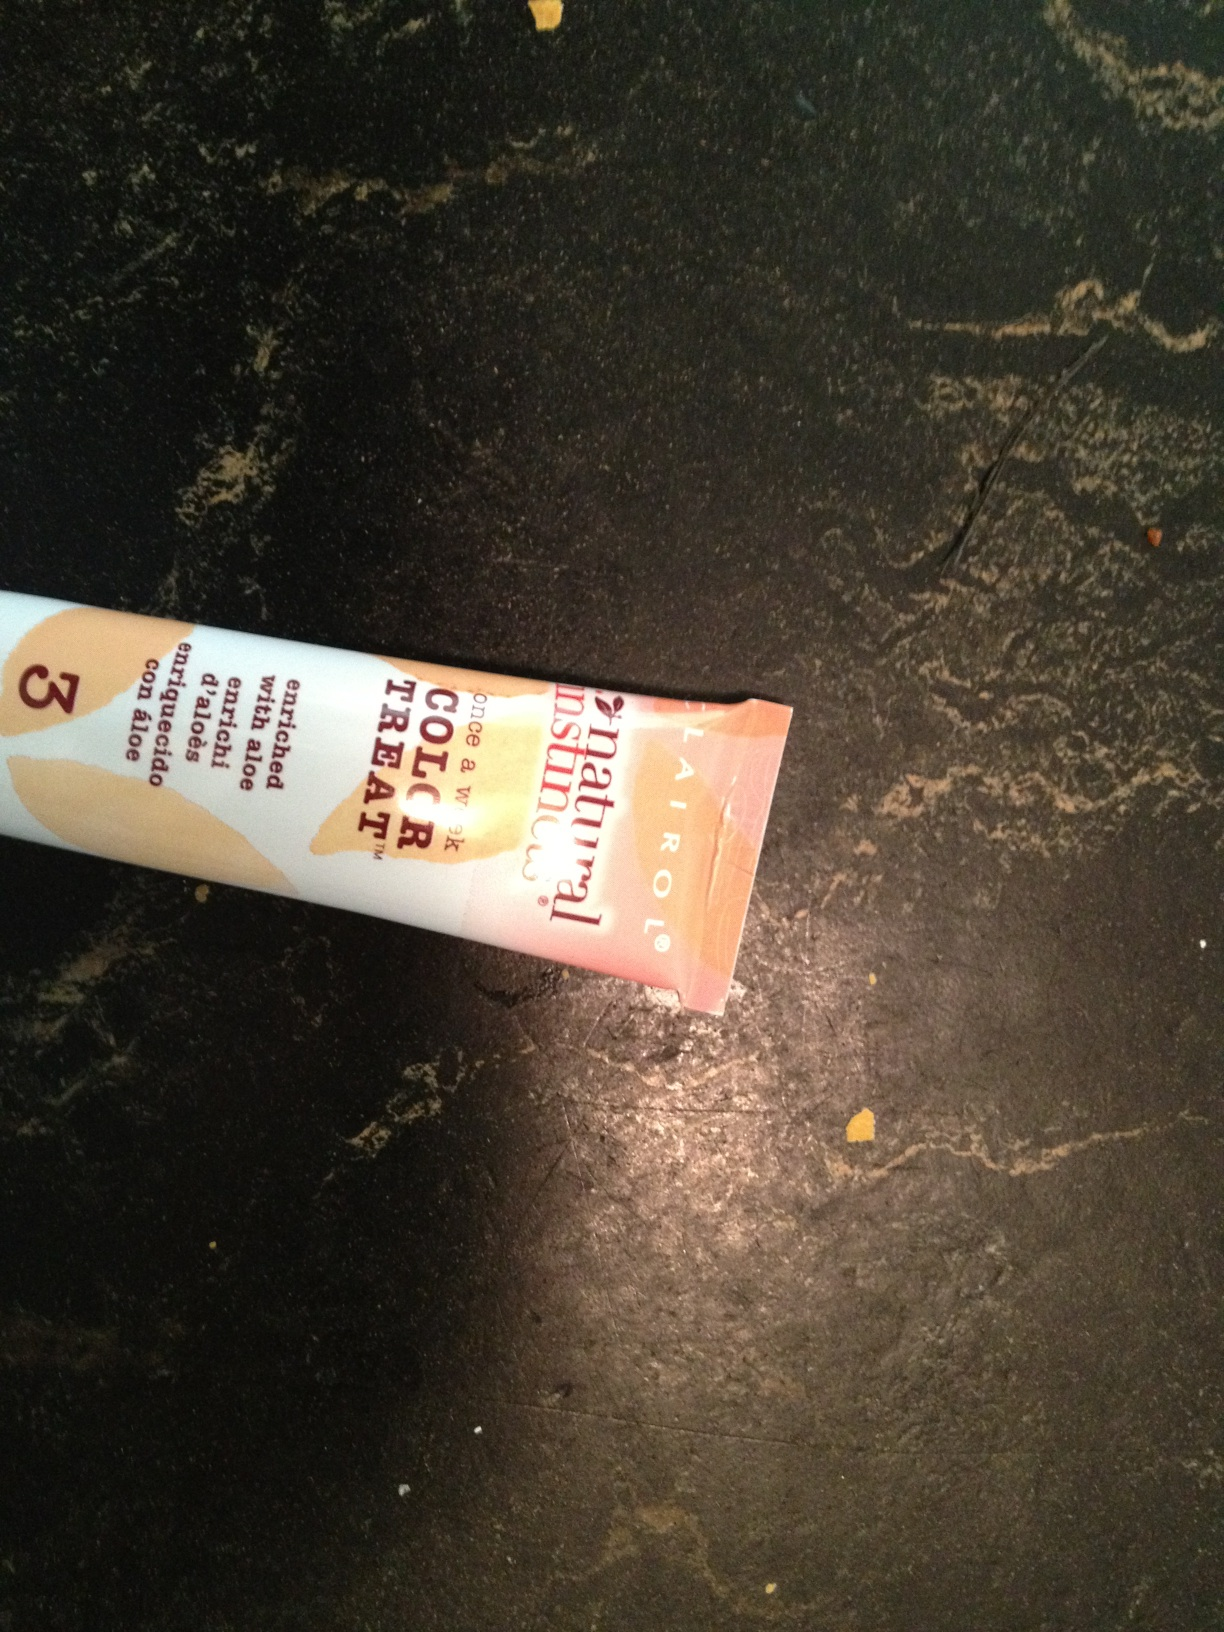What is the significance of having aloe in hair care products? Aloe is known for its soothing and moisturizing properties. In hair care products, it can help to calm the scalp, hydrate the hair, and provide a protective barrier that can be beneficial during the hair coloring process to minimize damage. Could you guess the type of product based on its tube shape and cap style? The tube shape and flip-top cap style are common for hair color treatments, conditioners, or other cream-based hair care products. It suggests that the product is likely meant to be squeezed out, and the cap design allows for easy one-handed use. 